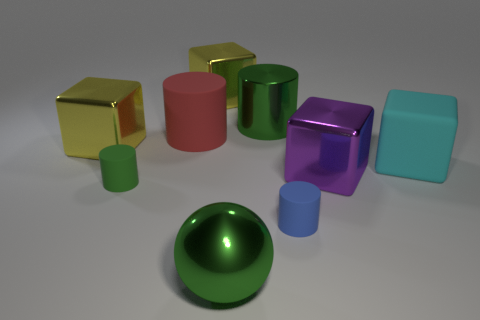Subtract all blue balls. How many yellow cubes are left? 2 Subtract all big rubber blocks. How many blocks are left? 3 Subtract all purple cubes. How many cubes are left? 3 Add 1 tiny purple shiny things. How many objects exist? 10 Subtract all yellow cylinders. Subtract all cyan blocks. How many cylinders are left? 4 Subtract all cubes. How many objects are left? 5 Subtract 1 purple cubes. How many objects are left? 8 Subtract all shiny cylinders. Subtract all green metallic cylinders. How many objects are left? 7 Add 2 big green shiny cylinders. How many big green shiny cylinders are left? 3 Add 9 yellow matte spheres. How many yellow matte spheres exist? 9 